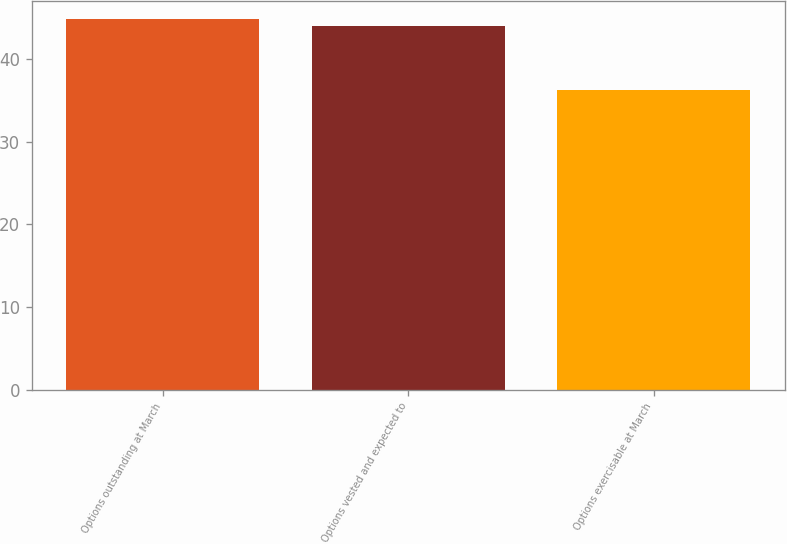<chart> <loc_0><loc_0><loc_500><loc_500><bar_chart><fcel>Options outstanding at March<fcel>Options vested and expected to<fcel>Options exercisable at March<nl><fcel>44.77<fcel>43.97<fcel>36.22<nl></chart> 